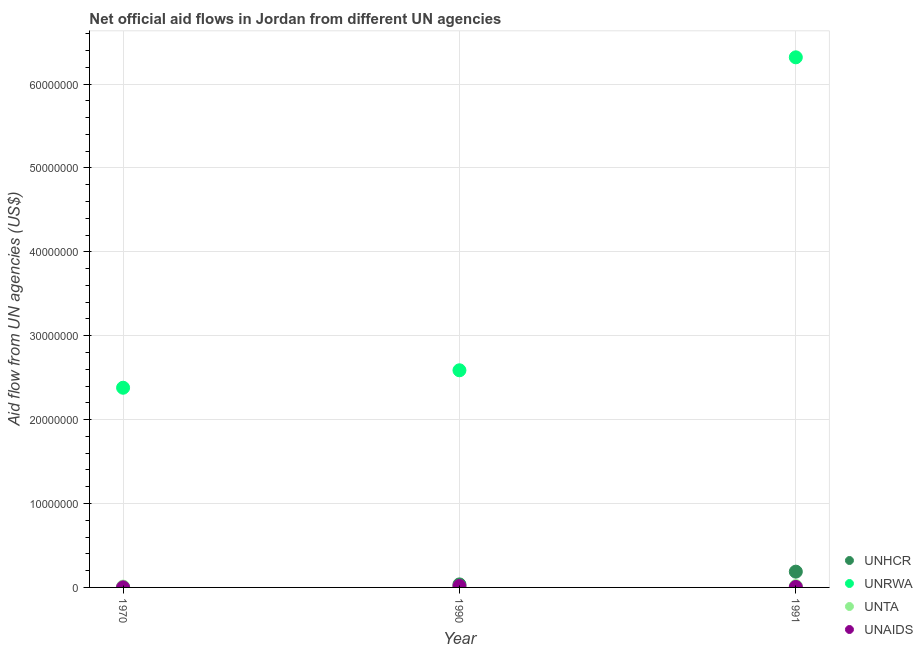What is the amount of aid given by unhcr in 1991?
Provide a succinct answer. 1.88e+06. Across all years, what is the maximum amount of aid given by unta?
Provide a short and direct response. 1.60e+05. Across all years, what is the minimum amount of aid given by unaids?
Your answer should be very brief. 10000. In which year was the amount of aid given by unrwa minimum?
Ensure brevity in your answer.  1970. What is the total amount of aid given by unaids in the graph?
Provide a succinct answer. 2.40e+05. What is the difference between the amount of aid given by unhcr in 1990 and that in 1991?
Provide a short and direct response. -1.52e+06. What is the difference between the amount of aid given by unaids in 1970 and the amount of aid given by unrwa in 1991?
Your answer should be very brief. -6.32e+07. What is the average amount of aid given by unrwa per year?
Offer a terse response. 3.76e+07. In the year 1970, what is the difference between the amount of aid given by unhcr and amount of aid given by unrwa?
Offer a terse response. -2.38e+07. In how many years, is the amount of aid given by unta greater than 28000000 US$?
Provide a succinct answer. 0. Is the difference between the amount of aid given by unhcr in 1970 and 1991 greater than the difference between the amount of aid given by unta in 1970 and 1991?
Your answer should be very brief. No. What is the difference between the highest and the second highest amount of aid given by unta?
Your response must be concise. 4.00e+04. What is the difference between the highest and the lowest amount of aid given by unta?
Your response must be concise. 6.00e+04. Is the sum of the amount of aid given by unrwa in 1970 and 1991 greater than the maximum amount of aid given by unhcr across all years?
Give a very brief answer. Yes. Is it the case that in every year, the sum of the amount of aid given by unhcr and amount of aid given by unrwa is greater than the amount of aid given by unta?
Offer a terse response. Yes. Is the amount of aid given by unrwa strictly less than the amount of aid given by unhcr over the years?
Offer a terse response. No. How many dotlines are there?
Give a very brief answer. 4. How many years are there in the graph?
Your response must be concise. 3. Are the values on the major ticks of Y-axis written in scientific E-notation?
Keep it short and to the point. No. Does the graph contain any zero values?
Offer a terse response. No. How are the legend labels stacked?
Keep it short and to the point. Vertical. What is the title of the graph?
Your answer should be very brief. Net official aid flows in Jordan from different UN agencies. Does "Burnt food" appear as one of the legend labels in the graph?
Keep it short and to the point. No. What is the label or title of the Y-axis?
Keep it short and to the point. Aid flow from UN agencies (US$). What is the Aid flow from UN agencies (US$) in UNRWA in 1970?
Your answer should be compact. 2.38e+07. What is the Aid flow from UN agencies (US$) in UNTA in 1970?
Make the answer very short. 1.00e+05. What is the Aid flow from UN agencies (US$) of UNAIDS in 1970?
Your answer should be compact. 10000. What is the Aid flow from UN agencies (US$) of UNRWA in 1990?
Offer a terse response. 2.59e+07. What is the Aid flow from UN agencies (US$) of UNTA in 1990?
Your answer should be compact. 1.20e+05. What is the Aid flow from UN agencies (US$) in UNHCR in 1991?
Make the answer very short. 1.88e+06. What is the Aid flow from UN agencies (US$) of UNRWA in 1991?
Your answer should be compact. 6.32e+07. Across all years, what is the maximum Aid flow from UN agencies (US$) in UNHCR?
Your answer should be compact. 1.88e+06. Across all years, what is the maximum Aid flow from UN agencies (US$) of UNRWA?
Your answer should be compact. 6.32e+07. Across all years, what is the maximum Aid flow from UN agencies (US$) in UNAIDS?
Ensure brevity in your answer.  1.70e+05. Across all years, what is the minimum Aid flow from UN agencies (US$) of UNHCR?
Offer a terse response. 10000. Across all years, what is the minimum Aid flow from UN agencies (US$) in UNRWA?
Offer a terse response. 2.38e+07. What is the total Aid flow from UN agencies (US$) of UNHCR in the graph?
Your answer should be compact. 2.25e+06. What is the total Aid flow from UN agencies (US$) of UNRWA in the graph?
Your answer should be very brief. 1.13e+08. What is the total Aid flow from UN agencies (US$) of UNTA in the graph?
Your response must be concise. 3.80e+05. What is the difference between the Aid flow from UN agencies (US$) in UNHCR in 1970 and that in 1990?
Keep it short and to the point. -3.50e+05. What is the difference between the Aid flow from UN agencies (US$) in UNRWA in 1970 and that in 1990?
Offer a terse response. -2.08e+06. What is the difference between the Aid flow from UN agencies (US$) of UNTA in 1970 and that in 1990?
Give a very brief answer. -2.00e+04. What is the difference between the Aid flow from UN agencies (US$) of UNHCR in 1970 and that in 1991?
Keep it short and to the point. -1.87e+06. What is the difference between the Aid flow from UN agencies (US$) in UNRWA in 1970 and that in 1991?
Offer a terse response. -3.94e+07. What is the difference between the Aid flow from UN agencies (US$) of UNAIDS in 1970 and that in 1991?
Your answer should be compact. -5.00e+04. What is the difference between the Aid flow from UN agencies (US$) in UNHCR in 1990 and that in 1991?
Make the answer very short. -1.52e+06. What is the difference between the Aid flow from UN agencies (US$) of UNRWA in 1990 and that in 1991?
Give a very brief answer. -3.73e+07. What is the difference between the Aid flow from UN agencies (US$) in UNAIDS in 1990 and that in 1991?
Offer a terse response. 1.10e+05. What is the difference between the Aid flow from UN agencies (US$) of UNHCR in 1970 and the Aid flow from UN agencies (US$) of UNRWA in 1990?
Your answer should be compact. -2.59e+07. What is the difference between the Aid flow from UN agencies (US$) of UNHCR in 1970 and the Aid flow from UN agencies (US$) of UNTA in 1990?
Offer a terse response. -1.10e+05. What is the difference between the Aid flow from UN agencies (US$) in UNHCR in 1970 and the Aid flow from UN agencies (US$) in UNAIDS in 1990?
Your answer should be compact. -1.60e+05. What is the difference between the Aid flow from UN agencies (US$) in UNRWA in 1970 and the Aid flow from UN agencies (US$) in UNTA in 1990?
Your answer should be very brief. 2.37e+07. What is the difference between the Aid flow from UN agencies (US$) in UNRWA in 1970 and the Aid flow from UN agencies (US$) in UNAIDS in 1990?
Provide a succinct answer. 2.36e+07. What is the difference between the Aid flow from UN agencies (US$) in UNTA in 1970 and the Aid flow from UN agencies (US$) in UNAIDS in 1990?
Your response must be concise. -7.00e+04. What is the difference between the Aid flow from UN agencies (US$) of UNHCR in 1970 and the Aid flow from UN agencies (US$) of UNRWA in 1991?
Your response must be concise. -6.32e+07. What is the difference between the Aid flow from UN agencies (US$) of UNHCR in 1970 and the Aid flow from UN agencies (US$) of UNTA in 1991?
Offer a terse response. -1.50e+05. What is the difference between the Aid flow from UN agencies (US$) of UNHCR in 1970 and the Aid flow from UN agencies (US$) of UNAIDS in 1991?
Provide a succinct answer. -5.00e+04. What is the difference between the Aid flow from UN agencies (US$) in UNRWA in 1970 and the Aid flow from UN agencies (US$) in UNTA in 1991?
Give a very brief answer. 2.36e+07. What is the difference between the Aid flow from UN agencies (US$) of UNRWA in 1970 and the Aid flow from UN agencies (US$) of UNAIDS in 1991?
Provide a succinct answer. 2.37e+07. What is the difference between the Aid flow from UN agencies (US$) in UNTA in 1970 and the Aid flow from UN agencies (US$) in UNAIDS in 1991?
Make the answer very short. 4.00e+04. What is the difference between the Aid flow from UN agencies (US$) of UNHCR in 1990 and the Aid flow from UN agencies (US$) of UNRWA in 1991?
Offer a very short reply. -6.28e+07. What is the difference between the Aid flow from UN agencies (US$) in UNHCR in 1990 and the Aid flow from UN agencies (US$) in UNTA in 1991?
Keep it short and to the point. 2.00e+05. What is the difference between the Aid flow from UN agencies (US$) of UNHCR in 1990 and the Aid flow from UN agencies (US$) of UNAIDS in 1991?
Provide a short and direct response. 3.00e+05. What is the difference between the Aid flow from UN agencies (US$) in UNRWA in 1990 and the Aid flow from UN agencies (US$) in UNTA in 1991?
Your answer should be compact. 2.57e+07. What is the difference between the Aid flow from UN agencies (US$) in UNRWA in 1990 and the Aid flow from UN agencies (US$) in UNAIDS in 1991?
Your response must be concise. 2.58e+07. What is the difference between the Aid flow from UN agencies (US$) of UNTA in 1990 and the Aid flow from UN agencies (US$) of UNAIDS in 1991?
Offer a terse response. 6.00e+04. What is the average Aid flow from UN agencies (US$) of UNHCR per year?
Ensure brevity in your answer.  7.50e+05. What is the average Aid flow from UN agencies (US$) in UNRWA per year?
Offer a very short reply. 3.76e+07. What is the average Aid flow from UN agencies (US$) in UNTA per year?
Give a very brief answer. 1.27e+05. What is the average Aid flow from UN agencies (US$) in UNAIDS per year?
Ensure brevity in your answer.  8.00e+04. In the year 1970, what is the difference between the Aid flow from UN agencies (US$) in UNHCR and Aid flow from UN agencies (US$) in UNRWA?
Keep it short and to the point. -2.38e+07. In the year 1970, what is the difference between the Aid flow from UN agencies (US$) of UNHCR and Aid flow from UN agencies (US$) of UNTA?
Give a very brief answer. -9.00e+04. In the year 1970, what is the difference between the Aid flow from UN agencies (US$) of UNHCR and Aid flow from UN agencies (US$) of UNAIDS?
Your answer should be very brief. 0. In the year 1970, what is the difference between the Aid flow from UN agencies (US$) in UNRWA and Aid flow from UN agencies (US$) in UNTA?
Offer a terse response. 2.37e+07. In the year 1970, what is the difference between the Aid flow from UN agencies (US$) in UNRWA and Aid flow from UN agencies (US$) in UNAIDS?
Make the answer very short. 2.38e+07. In the year 1970, what is the difference between the Aid flow from UN agencies (US$) in UNTA and Aid flow from UN agencies (US$) in UNAIDS?
Provide a short and direct response. 9.00e+04. In the year 1990, what is the difference between the Aid flow from UN agencies (US$) of UNHCR and Aid flow from UN agencies (US$) of UNRWA?
Offer a very short reply. -2.55e+07. In the year 1990, what is the difference between the Aid flow from UN agencies (US$) in UNHCR and Aid flow from UN agencies (US$) in UNTA?
Keep it short and to the point. 2.40e+05. In the year 1990, what is the difference between the Aid flow from UN agencies (US$) in UNRWA and Aid flow from UN agencies (US$) in UNTA?
Your answer should be compact. 2.58e+07. In the year 1990, what is the difference between the Aid flow from UN agencies (US$) in UNRWA and Aid flow from UN agencies (US$) in UNAIDS?
Offer a terse response. 2.57e+07. In the year 1990, what is the difference between the Aid flow from UN agencies (US$) in UNTA and Aid flow from UN agencies (US$) in UNAIDS?
Make the answer very short. -5.00e+04. In the year 1991, what is the difference between the Aid flow from UN agencies (US$) of UNHCR and Aid flow from UN agencies (US$) of UNRWA?
Provide a short and direct response. -6.13e+07. In the year 1991, what is the difference between the Aid flow from UN agencies (US$) in UNHCR and Aid flow from UN agencies (US$) in UNTA?
Your response must be concise. 1.72e+06. In the year 1991, what is the difference between the Aid flow from UN agencies (US$) of UNHCR and Aid flow from UN agencies (US$) of UNAIDS?
Provide a succinct answer. 1.82e+06. In the year 1991, what is the difference between the Aid flow from UN agencies (US$) of UNRWA and Aid flow from UN agencies (US$) of UNTA?
Your answer should be very brief. 6.30e+07. In the year 1991, what is the difference between the Aid flow from UN agencies (US$) of UNRWA and Aid flow from UN agencies (US$) of UNAIDS?
Give a very brief answer. 6.31e+07. What is the ratio of the Aid flow from UN agencies (US$) of UNHCR in 1970 to that in 1990?
Give a very brief answer. 0.03. What is the ratio of the Aid flow from UN agencies (US$) of UNRWA in 1970 to that in 1990?
Offer a terse response. 0.92. What is the ratio of the Aid flow from UN agencies (US$) of UNAIDS in 1970 to that in 1990?
Provide a short and direct response. 0.06. What is the ratio of the Aid flow from UN agencies (US$) of UNHCR in 1970 to that in 1991?
Provide a short and direct response. 0.01. What is the ratio of the Aid flow from UN agencies (US$) in UNRWA in 1970 to that in 1991?
Your answer should be very brief. 0.38. What is the ratio of the Aid flow from UN agencies (US$) of UNAIDS in 1970 to that in 1991?
Give a very brief answer. 0.17. What is the ratio of the Aid flow from UN agencies (US$) of UNHCR in 1990 to that in 1991?
Your answer should be very brief. 0.19. What is the ratio of the Aid flow from UN agencies (US$) of UNRWA in 1990 to that in 1991?
Your answer should be compact. 0.41. What is the ratio of the Aid flow from UN agencies (US$) of UNTA in 1990 to that in 1991?
Give a very brief answer. 0.75. What is the ratio of the Aid flow from UN agencies (US$) in UNAIDS in 1990 to that in 1991?
Provide a short and direct response. 2.83. What is the difference between the highest and the second highest Aid flow from UN agencies (US$) of UNHCR?
Give a very brief answer. 1.52e+06. What is the difference between the highest and the second highest Aid flow from UN agencies (US$) of UNRWA?
Make the answer very short. 3.73e+07. What is the difference between the highest and the second highest Aid flow from UN agencies (US$) in UNTA?
Offer a terse response. 4.00e+04. What is the difference between the highest and the lowest Aid flow from UN agencies (US$) in UNHCR?
Keep it short and to the point. 1.87e+06. What is the difference between the highest and the lowest Aid flow from UN agencies (US$) in UNRWA?
Offer a terse response. 3.94e+07. What is the difference between the highest and the lowest Aid flow from UN agencies (US$) in UNTA?
Your answer should be very brief. 6.00e+04. 